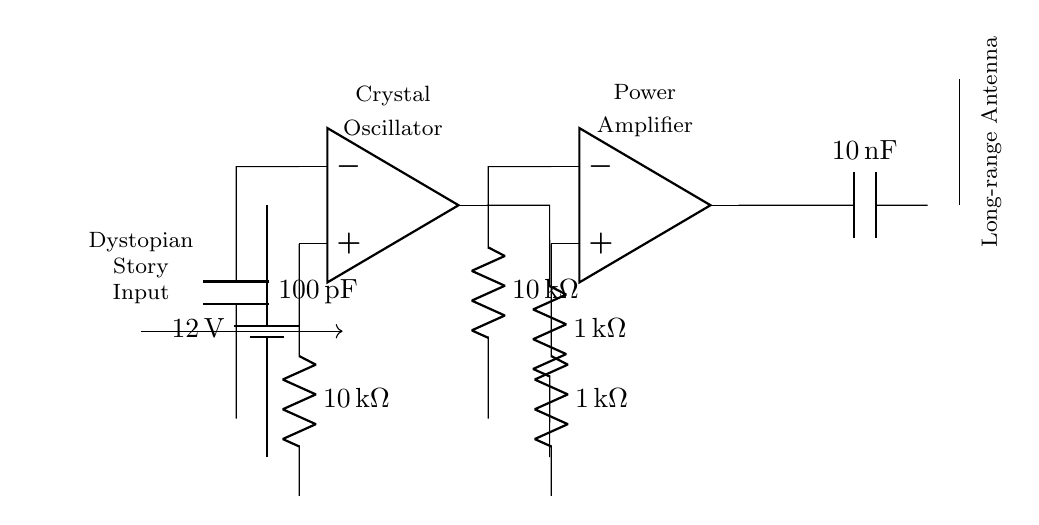What is the voltage provided by the battery? The battery in the circuit is labeled as providing a voltage of 12 volts, which is indicated next to the battery symbol in the diagram.
Answer: 12 volts What type of oscillator is used in this circuit? The diagram shows a component labeled as a crystal oscillator, which is identified at the top left of the circuit and is associated with frequency generation.
Answer: Crystal oscillator What is the resistance value of the resistor connected to the output of the amplifier? The resistor labeled at the output of the amplifier is indicated as having a resistance of 1 kilo-ohm, which can be seen in the component's labeling in the circuit.
Answer: 1 kilo-ohm How many capacitors are present in the circuit? There are two capacitors indicated in the circuit diagram; one is labeled with a capacitance of 100 picofarads and the other with 10 nanofarads, making a total of two capacitors.
Answer: Two What is the purpose of the antenna in this circuit? The antenna, labeled in the diagram, is essential for transmitting radio frequencies over long distances, allowing the broadcasting of signals—specifically, the dystopian stories in this context.
Answer: Transmitting radio frequencies What is the function of the power amplifier in this circuit? The power amplifier amplifies the input signal received from the oscillator, increasing its power before sending it to the antenna for transmission. This function is critical for ensuring the signal can reach remote locations.
Answer: To amplify the signal What does the input labeled "Dystopian Story Input" represent? The label indicates that the circuit receives text-based content—specifically, dystopian stories—which will be modulated and transmitted through the radio waves by the circuit components.
Answer: Dystopian stories 